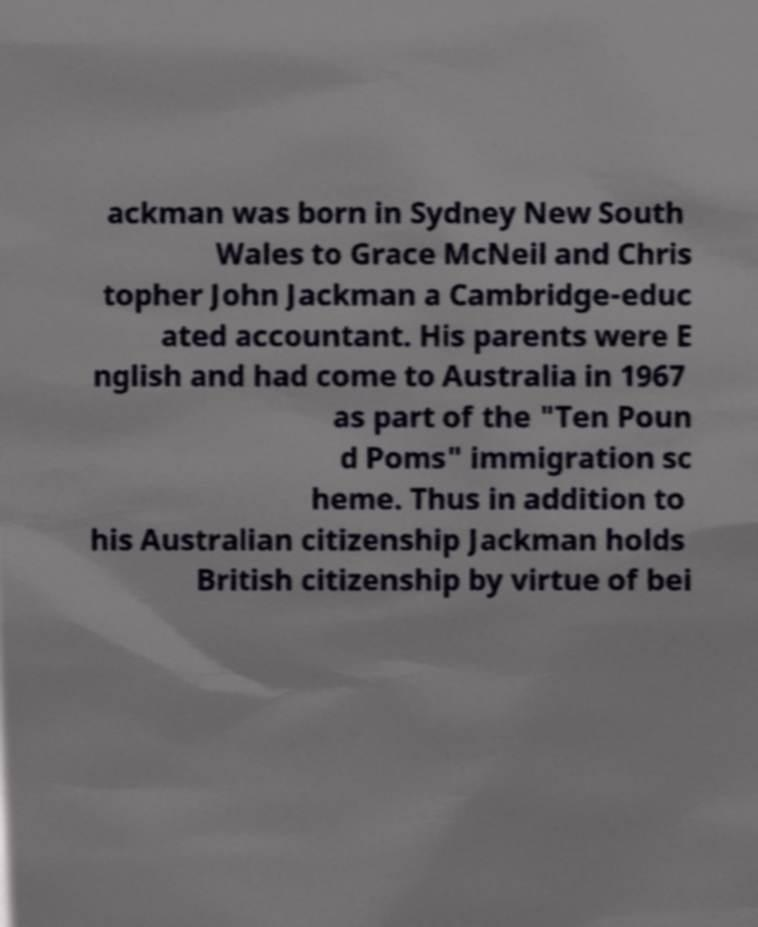There's text embedded in this image that I need extracted. Can you transcribe it verbatim? ackman was born in Sydney New South Wales to Grace McNeil and Chris topher John Jackman a Cambridge-educ ated accountant. His parents were E nglish and had come to Australia in 1967 as part of the "Ten Poun d Poms" immigration sc heme. Thus in addition to his Australian citizenship Jackman holds British citizenship by virtue of bei 